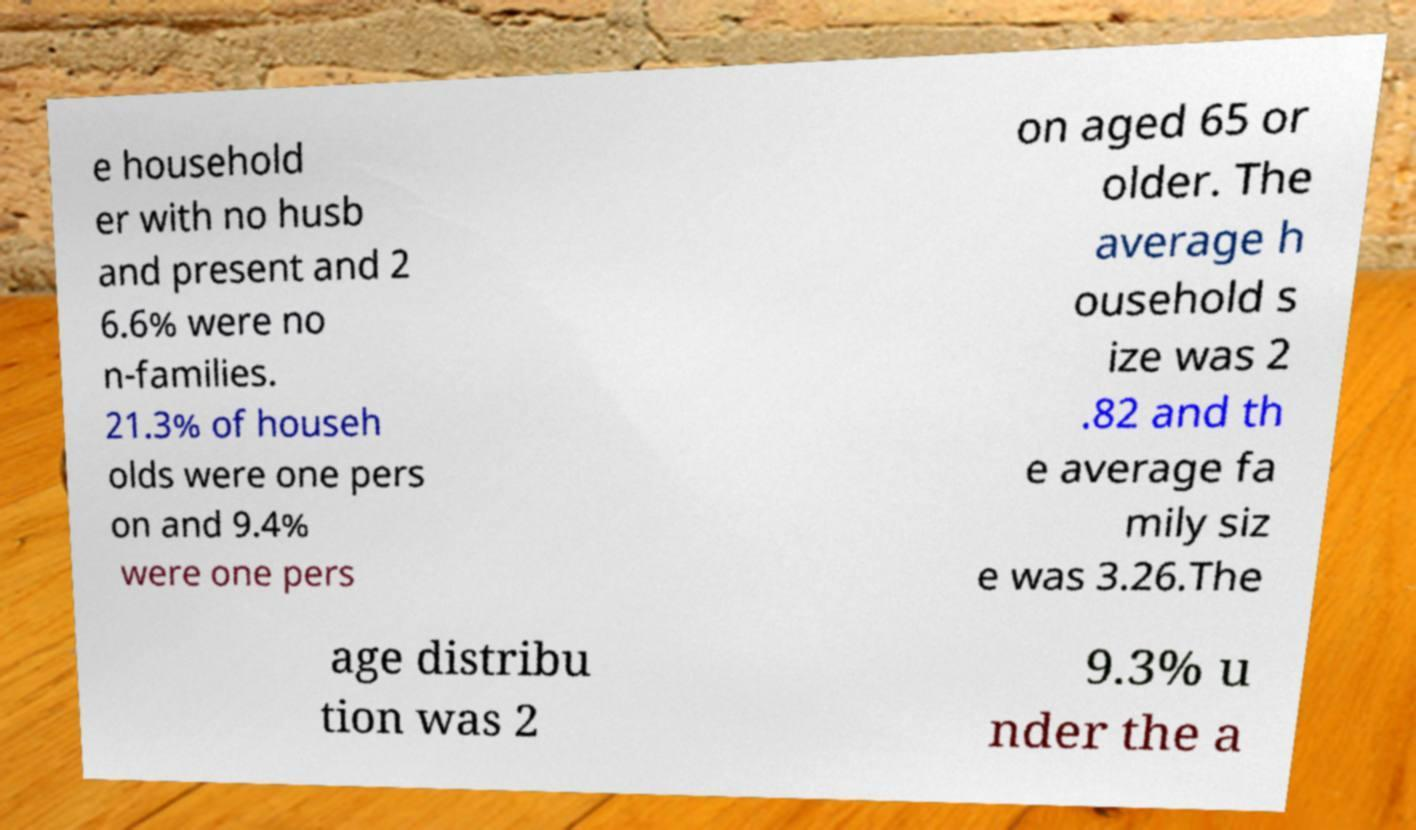Please read and relay the text visible in this image. What does it say? e household er with no husb and present and 2 6.6% were no n-families. 21.3% of househ olds were one pers on and 9.4% were one pers on aged 65 or older. The average h ousehold s ize was 2 .82 and th e average fa mily siz e was 3.26.The age distribu tion was 2 9.3% u nder the a 